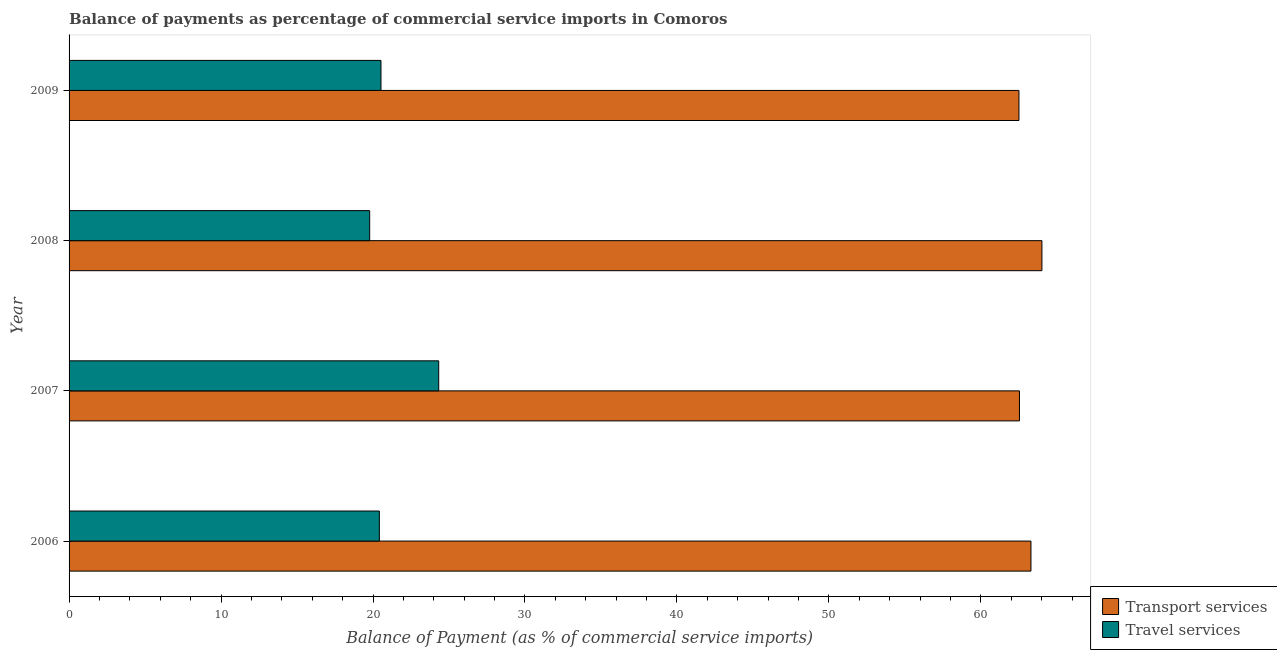How many different coloured bars are there?
Give a very brief answer. 2. How many groups of bars are there?
Your answer should be very brief. 4. Are the number of bars per tick equal to the number of legend labels?
Keep it short and to the point. Yes. Are the number of bars on each tick of the Y-axis equal?
Your answer should be very brief. Yes. How many bars are there on the 1st tick from the top?
Your answer should be compact. 2. In how many cases, is the number of bars for a given year not equal to the number of legend labels?
Provide a short and direct response. 0. What is the balance of payments of travel services in 2009?
Your answer should be very brief. 20.52. Across all years, what is the maximum balance of payments of transport services?
Give a very brief answer. 64.02. Across all years, what is the minimum balance of payments of travel services?
Offer a very short reply. 19.78. In which year was the balance of payments of travel services maximum?
Provide a short and direct response. 2007. What is the total balance of payments of transport services in the graph?
Keep it short and to the point. 252.36. What is the difference between the balance of payments of travel services in 2007 and that in 2009?
Keep it short and to the point. 3.8. What is the difference between the balance of payments of travel services in 2008 and the balance of payments of transport services in 2006?
Make the answer very short. -43.52. What is the average balance of payments of transport services per year?
Provide a succinct answer. 63.09. In the year 2006, what is the difference between the balance of payments of travel services and balance of payments of transport services?
Ensure brevity in your answer.  -42.88. What is the ratio of the balance of payments of travel services in 2006 to that in 2009?
Provide a short and direct response. 0.99. What is the difference between the highest and the second highest balance of payments of travel services?
Your answer should be very brief. 3.8. What is the difference between the highest and the lowest balance of payments of travel services?
Give a very brief answer. 4.54. In how many years, is the balance of payments of transport services greater than the average balance of payments of transport services taken over all years?
Make the answer very short. 2. What does the 2nd bar from the top in 2009 represents?
Give a very brief answer. Transport services. What does the 1st bar from the bottom in 2008 represents?
Ensure brevity in your answer.  Transport services. How many bars are there?
Your response must be concise. 8. Are all the bars in the graph horizontal?
Keep it short and to the point. Yes. How many years are there in the graph?
Keep it short and to the point. 4. Are the values on the major ticks of X-axis written in scientific E-notation?
Make the answer very short. No. Does the graph contain grids?
Keep it short and to the point. No. How many legend labels are there?
Your answer should be very brief. 2. What is the title of the graph?
Ensure brevity in your answer.  Balance of payments as percentage of commercial service imports in Comoros. What is the label or title of the X-axis?
Give a very brief answer. Balance of Payment (as % of commercial service imports). What is the label or title of the Y-axis?
Give a very brief answer. Year. What is the Balance of Payment (as % of commercial service imports) of Transport services in 2006?
Your answer should be very brief. 63.3. What is the Balance of Payment (as % of commercial service imports) of Travel services in 2006?
Your answer should be compact. 20.42. What is the Balance of Payment (as % of commercial service imports) in Transport services in 2007?
Give a very brief answer. 62.54. What is the Balance of Payment (as % of commercial service imports) of Travel services in 2007?
Keep it short and to the point. 24.32. What is the Balance of Payment (as % of commercial service imports) in Transport services in 2008?
Offer a very short reply. 64.02. What is the Balance of Payment (as % of commercial service imports) in Travel services in 2008?
Your answer should be compact. 19.78. What is the Balance of Payment (as % of commercial service imports) of Transport services in 2009?
Your answer should be very brief. 62.51. What is the Balance of Payment (as % of commercial service imports) of Travel services in 2009?
Your answer should be compact. 20.52. Across all years, what is the maximum Balance of Payment (as % of commercial service imports) of Transport services?
Offer a very short reply. 64.02. Across all years, what is the maximum Balance of Payment (as % of commercial service imports) of Travel services?
Your response must be concise. 24.32. Across all years, what is the minimum Balance of Payment (as % of commercial service imports) of Transport services?
Keep it short and to the point. 62.51. Across all years, what is the minimum Balance of Payment (as % of commercial service imports) in Travel services?
Ensure brevity in your answer.  19.78. What is the total Balance of Payment (as % of commercial service imports) in Transport services in the graph?
Offer a very short reply. 252.36. What is the total Balance of Payment (as % of commercial service imports) in Travel services in the graph?
Provide a succinct answer. 85.05. What is the difference between the Balance of Payment (as % of commercial service imports) in Transport services in 2006 and that in 2007?
Provide a succinct answer. 0.76. What is the difference between the Balance of Payment (as % of commercial service imports) in Travel services in 2006 and that in 2007?
Offer a very short reply. -3.91. What is the difference between the Balance of Payment (as % of commercial service imports) of Transport services in 2006 and that in 2008?
Make the answer very short. -0.72. What is the difference between the Balance of Payment (as % of commercial service imports) in Travel services in 2006 and that in 2008?
Your answer should be very brief. 0.64. What is the difference between the Balance of Payment (as % of commercial service imports) in Transport services in 2006 and that in 2009?
Give a very brief answer. 0.79. What is the difference between the Balance of Payment (as % of commercial service imports) of Travel services in 2006 and that in 2009?
Offer a terse response. -0.11. What is the difference between the Balance of Payment (as % of commercial service imports) of Transport services in 2007 and that in 2008?
Offer a terse response. -1.48. What is the difference between the Balance of Payment (as % of commercial service imports) in Travel services in 2007 and that in 2008?
Make the answer very short. 4.54. What is the difference between the Balance of Payment (as % of commercial service imports) of Transport services in 2007 and that in 2009?
Your answer should be compact. 0.03. What is the difference between the Balance of Payment (as % of commercial service imports) of Transport services in 2008 and that in 2009?
Ensure brevity in your answer.  1.51. What is the difference between the Balance of Payment (as % of commercial service imports) of Travel services in 2008 and that in 2009?
Offer a terse response. -0.74. What is the difference between the Balance of Payment (as % of commercial service imports) in Transport services in 2006 and the Balance of Payment (as % of commercial service imports) in Travel services in 2007?
Provide a short and direct response. 38.97. What is the difference between the Balance of Payment (as % of commercial service imports) of Transport services in 2006 and the Balance of Payment (as % of commercial service imports) of Travel services in 2008?
Your answer should be very brief. 43.52. What is the difference between the Balance of Payment (as % of commercial service imports) of Transport services in 2006 and the Balance of Payment (as % of commercial service imports) of Travel services in 2009?
Offer a terse response. 42.77. What is the difference between the Balance of Payment (as % of commercial service imports) in Transport services in 2007 and the Balance of Payment (as % of commercial service imports) in Travel services in 2008?
Provide a short and direct response. 42.76. What is the difference between the Balance of Payment (as % of commercial service imports) of Transport services in 2007 and the Balance of Payment (as % of commercial service imports) of Travel services in 2009?
Your answer should be compact. 42.01. What is the difference between the Balance of Payment (as % of commercial service imports) in Transport services in 2008 and the Balance of Payment (as % of commercial service imports) in Travel services in 2009?
Keep it short and to the point. 43.49. What is the average Balance of Payment (as % of commercial service imports) of Transport services per year?
Your answer should be compact. 63.09. What is the average Balance of Payment (as % of commercial service imports) in Travel services per year?
Give a very brief answer. 21.26. In the year 2006, what is the difference between the Balance of Payment (as % of commercial service imports) of Transport services and Balance of Payment (as % of commercial service imports) of Travel services?
Ensure brevity in your answer.  42.88. In the year 2007, what is the difference between the Balance of Payment (as % of commercial service imports) of Transport services and Balance of Payment (as % of commercial service imports) of Travel services?
Make the answer very short. 38.21. In the year 2008, what is the difference between the Balance of Payment (as % of commercial service imports) in Transport services and Balance of Payment (as % of commercial service imports) in Travel services?
Make the answer very short. 44.24. In the year 2009, what is the difference between the Balance of Payment (as % of commercial service imports) of Transport services and Balance of Payment (as % of commercial service imports) of Travel services?
Keep it short and to the point. 41.98. What is the ratio of the Balance of Payment (as % of commercial service imports) in Transport services in 2006 to that in 2007?
Your answer should be compact. 1.01. What is the ratio of the Balance of Payment (as % of commercial service imports) in Travel services in 2006 to that in 2007?
Offer a very short reply. 0.84. What is the ratio of the Balance of Payment (as % of commercial service imports) of Transport services in 2006 to that in 2008?
Provide a short and direct response. 0.99. What is the ratio of the Balance of Payment (as % of commercial service imports) of Travel services in 2006 to that in 2008?
Your answer should be compact. 1.03. What is the ratio of the Balance of Payment (as % of commercial service imports) of Transport services in 2006 to that in 2009?
Keep it short and to the point. 1.01. What is the ratio of the Balance of Payment (as % of commercial service imports) of Travel services in 2006 to that in 2009?
Your answer should be very brief. 0.99. What is the ratio of the Balance of Payment (as % of commercial service imports) of Transport services in 2007 to that in 2008?
Your answer should be very brief. 0.98. What is the ratio of the Balance of Payment (as % of commercial service imports) of Travel services in 2007 to that in 2008?
Make the answer very short. 1.23. What is the ratio of the Balance of Payment (as % of commercial service imports) in Transport services in 2007 to that in 2009?
Your answer should be very brief. 1. What is the ratio of the Balance of Payment (as % of commercial service imports) of Travel services in 2007 to that in 2009?
Your answer should be very brief. 1.19. What is the ratio of the Balance of Payment (as % of commercial service imports) in Transport services in 2008 to that in 2009?
Your response must be concise. 1.02. What is the ratio of the Balance of Payment (as % of commercial service imports) in Travel services in 2008 to that in 2009?
Keep it short and to the point. 0.96. What is the difference between the highest and the second highest Balance of Payment (as % of commercial service imports) of Transport services?
Offer a very short reply. 0.72. What is the difference between the highest and the lowest Balance of Payment (as % of commercial service imports) of Transport services?
Give a very brief answer. 1.51. What is the difference between the highest and the lowest Balance of Payment (as % of commercial service imports) in Travel services?
Offer a terse response. 4.54. 